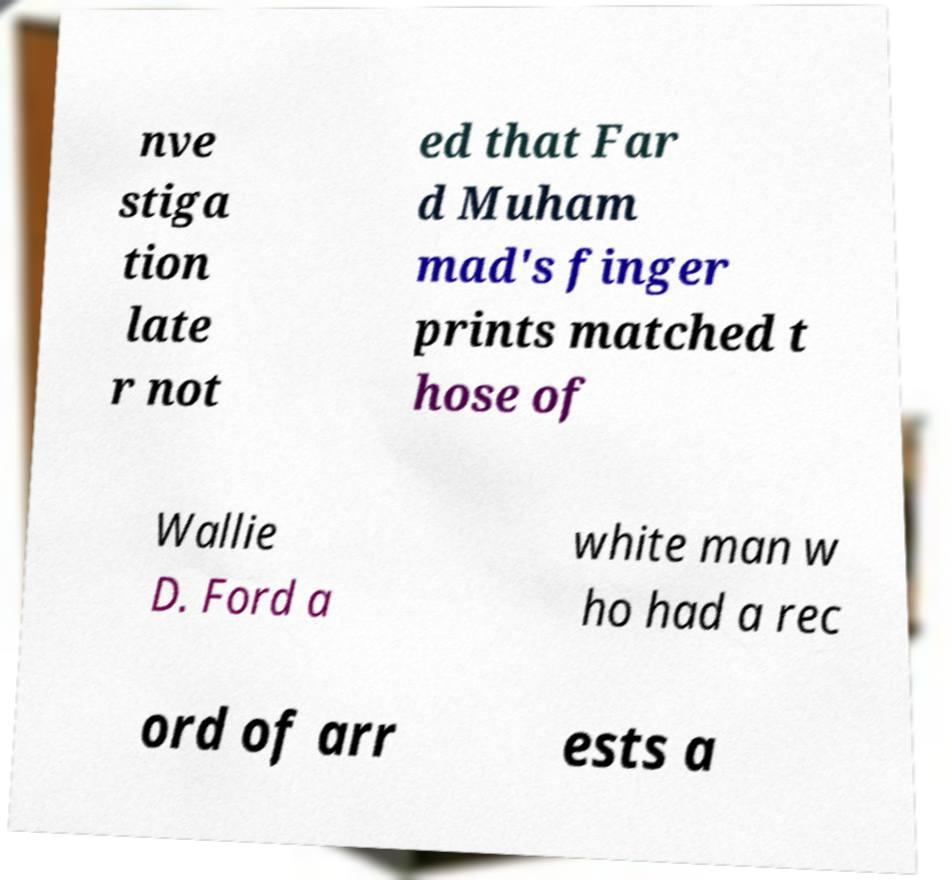For documentation purposes, I need the text within this image transcribed. Could you provide that? nve stiga tion late r not ed that Far d Muham mad's finger prints matched t hose of Wallie D. Ford a white man w ho had a rec ord of arr ests a 